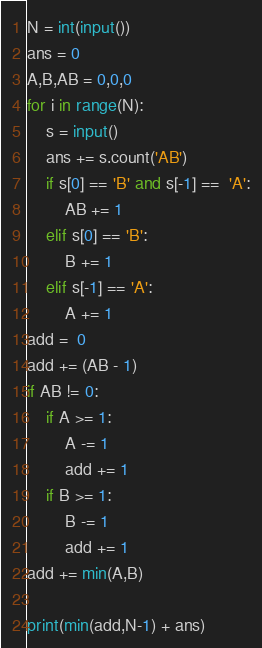Convert code to text. <code><loc_0><loc_0><loc_500><loc_500><_Python_>N = int(input())
ans = 0
A,B,AB = 0,0,0
for i in range(N):
    s = input()
    ans += s.count('AB')
    if s[0] == 'B' and s[-1] ==  'A':
        AB += 1
    elif s[0] == 'B':
        B += 1
    elif s[-1] == 'A':
        A += 1
add =  0
add += (AB - 1)
if AB != 0:
    if A >= 1:
        A -= 1
        add += 1
    if B >= 1:
        B -= 1
        add += 1
add += min(A,B)

print(min(add,N-1) + ans)</code> 